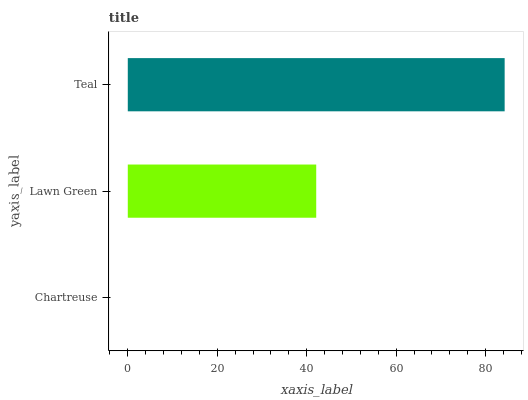Is Chartreuse the minimum?
Answer yes or no. Yes. Is Teal the maximum?
Answer yes or no. Yes. Is Lawn Green the minimum?
Answer yes or no. No. Is Lawn Green the maximum?
Answer yes or no. No. Is Lawn Green greater than Chartreuse?
Answer yes or no. Yes. Is Chartreuse less than Lawn Green?
Answer yes or no. Yes. Is Chartreuse greater than Lawn Green?
Answer yes or no. No. Is Lawn Green less than Chartreuse?
Answer yes or no. No. Is Lawn Green the high median?
Answer yes or no. Yes. Is Lawn Green the low median?
Answer yes or no. Yes. Is Chartreuse the high median?
Answer yes or no. No. Is Chartreuse the low median?
Answer yes or no. No. 